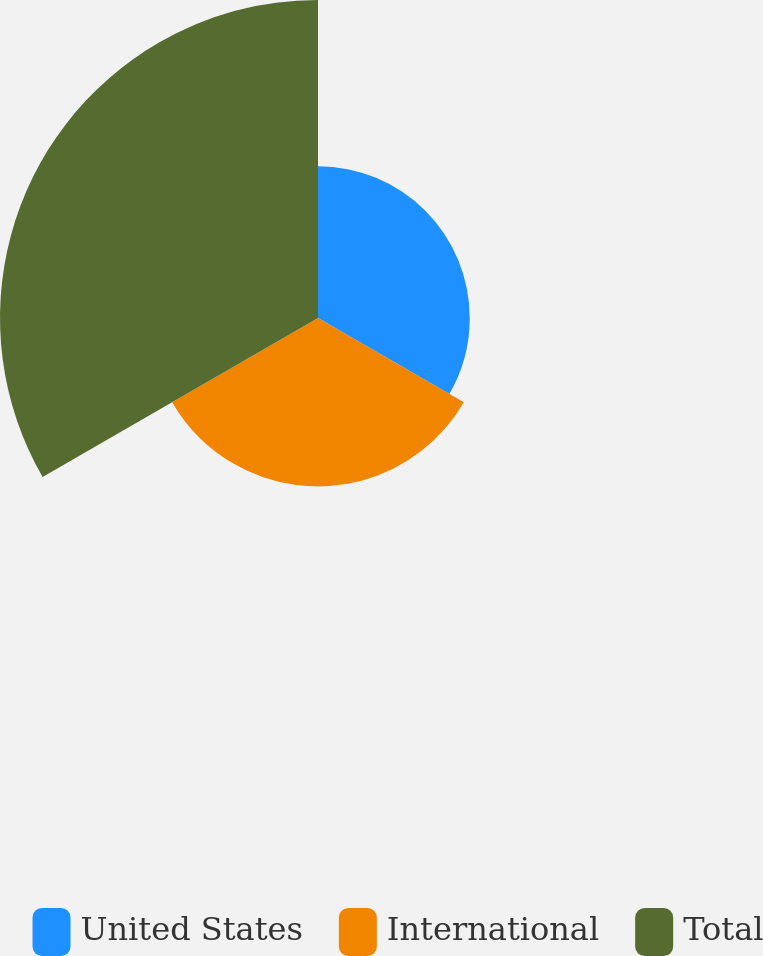Convert chart. <chart><loc_0><loc_0><loc_500><loc_500><pie_chart><fcel>United States<fcel>International<fcel>Total<nl><fcel>23.78%<fcel>26.39%<fcel>49.83%<nl></chart> 